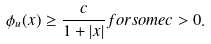Convert formula to latex. <formula><loc_0><loc_0><loc_500><loc_500>\phi _ { u } ( x ) \geq \frac { c } { 1 + | x | } f o r s o m e c > 0 .</formula> 